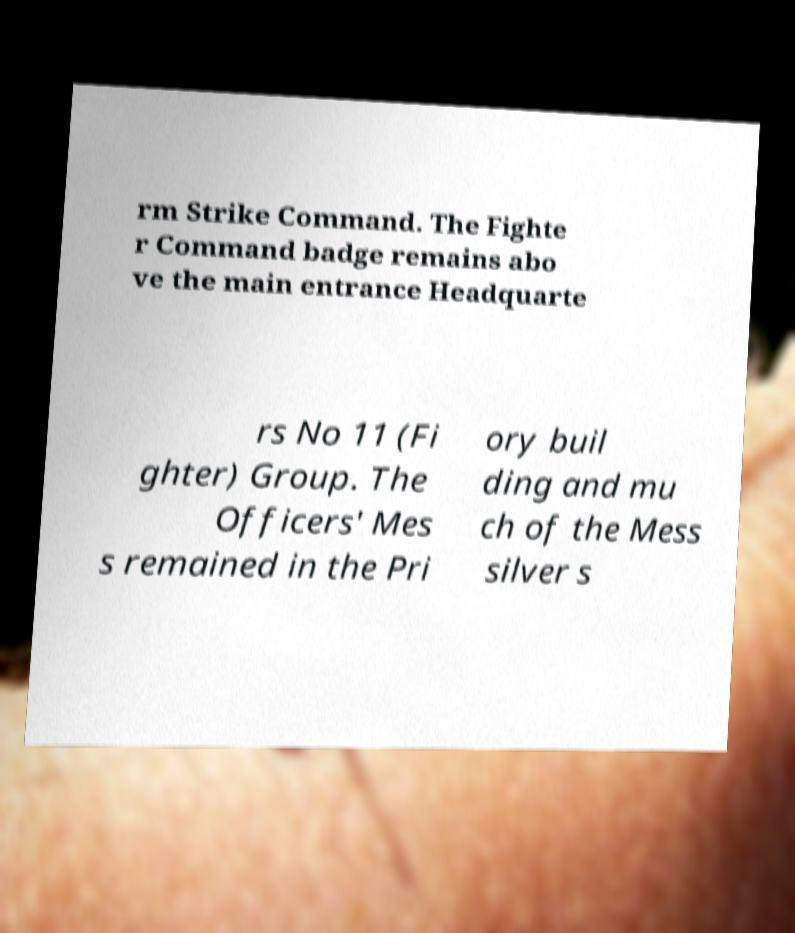What messages or text are displayed in this image? I need them in a readable, typed format. rm Strike Command. The Fighte r Command badge remains abo ve the main entrance Headquarte rs No 11 (Fi ghter) Group. The Officers' Mes s remained in the Pri ory buil ding and mu ch of the Mess silver s 